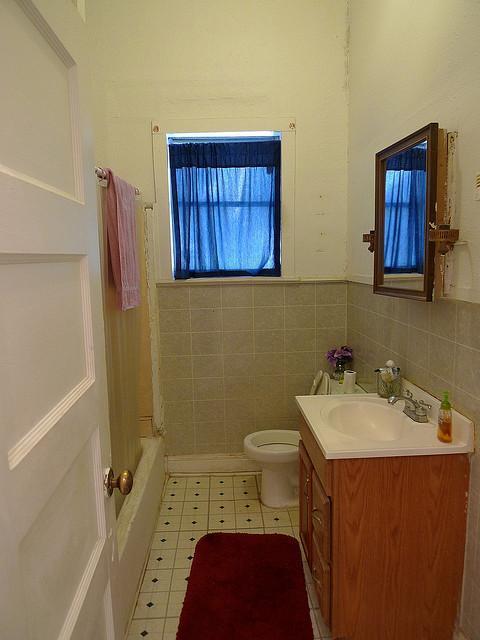How many beds are in this room?
Give a very brief answer. 0. 